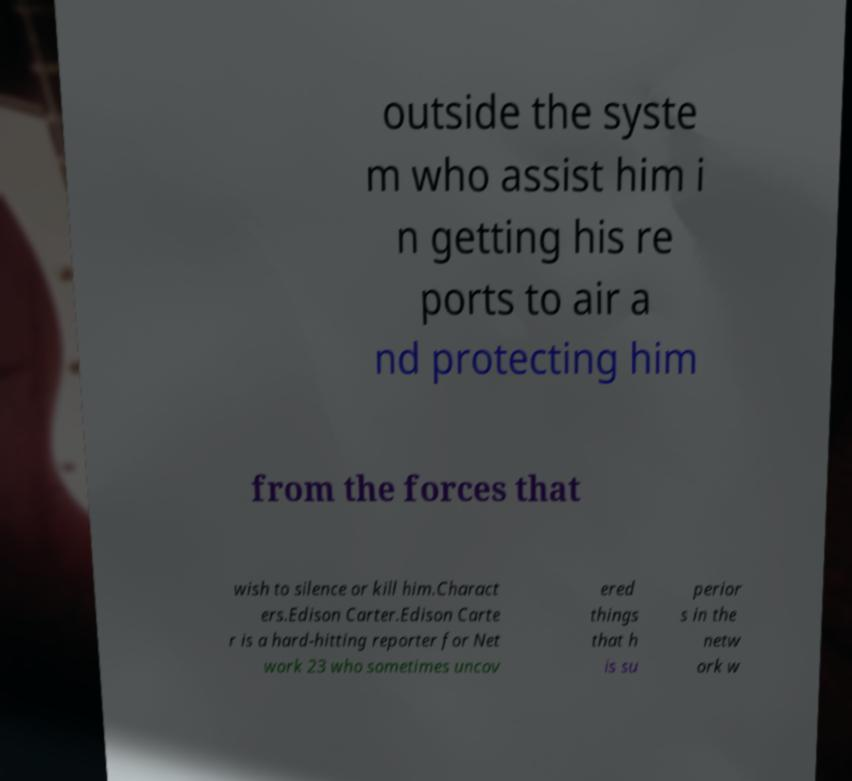Please identify and transcribe the text found in this image. outside the syste m who assist him i n getting his re ports to air a nd protecting him from the forces that wish to silence or kill him.Charact ers.Edison Carter.Edison Carte r is a hard-hitting reporter for Net work 23 who sometimes uncov ered things that h is su perior s in the netw ork w 